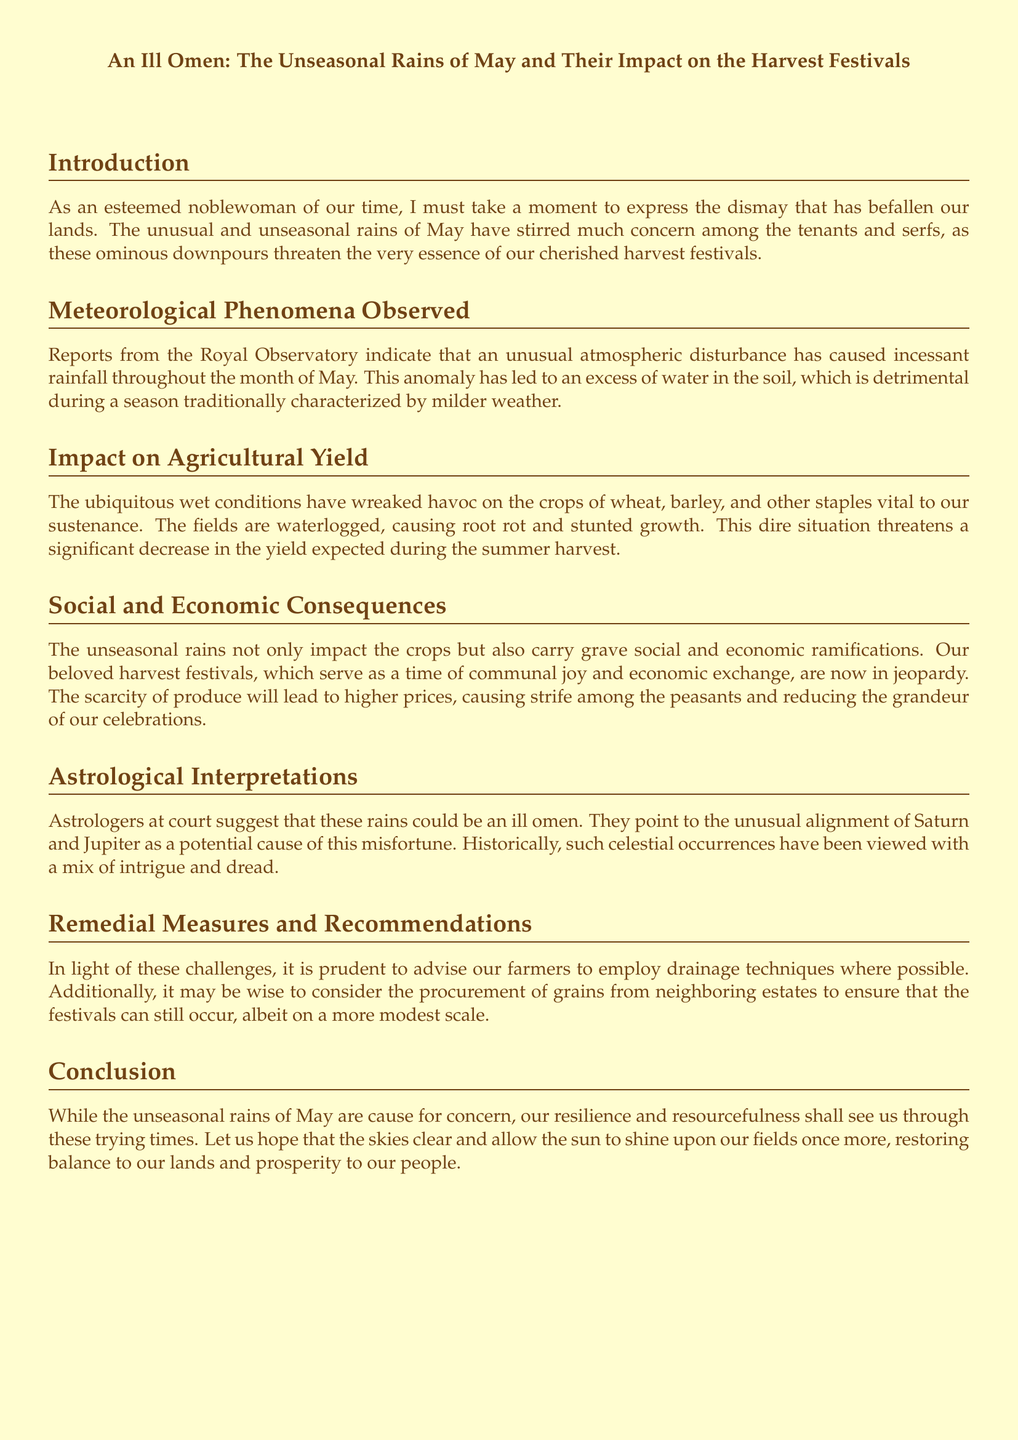what is the title of the document? The title is prominently displayed at the top of the document, which indicates the main subject matter.
Answer: An Ill Omen: The Unseasonal Rains of May and Their Impact on the Harvest Festivals what month experienced the unusual rains? The document specifically states that the rains occurred during May, highlighting the unusual weather pattern during this time.
Answer: May what crops are mentioned as affected by the wet conditions? The document lists several specific crops that are suffering due to the weather, providing insight into the agricultural impact.
Answer: wheat, barley what economic effect is anticipated due to the rains? The document discusses the potential consequences for both the economy and social order as a result of the weather, highlighting a specific concern.
Answer: higher prices which two planets are associated with the ill omen? The document references astrological interpretations that suggest celestial events are linked to the unfortunate weather, naming the specific planets involved.
Answer: Saturn and Jupiter what is a recommended remedial measure for farmers? The document offers practical advice on how to manage the agricultural impact of the severe weather conditions, suggesting an actionable solution.
Answer: drainage techniques how does the document classify the rains of May? The document provides a descriptive term for the rains, indicating the overall sentiment expressed towards this weather situation and its implications.
Answer: unseasonal what aspect of society do harvest festivals represent? The document elaborates on the nature of harvest festivals, specifically touching on their importance to community interaction and celebration.
Answer: communal joy 